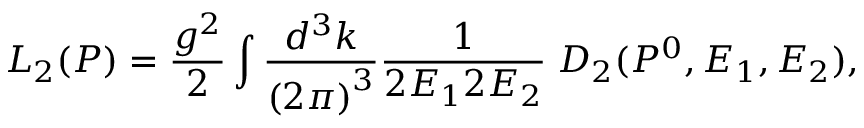Convert formula to latex. <formula><loc_0><loc_0><loc_500><loc_500>L _ { 2 } ( P ) = \frac { g ^ { 2 } } { 2 } \int \frac { d ^ { 3 } k } { \left ( 2 \pi \right ) ^ { 3 } } \frac { 1 } 2 E _ { 1 } 2 E _ { 2 } } \, D _ { 2 } ( P ^ { 0 } , E _ { 1 } , E _ { 2 } ) ,</formula> 